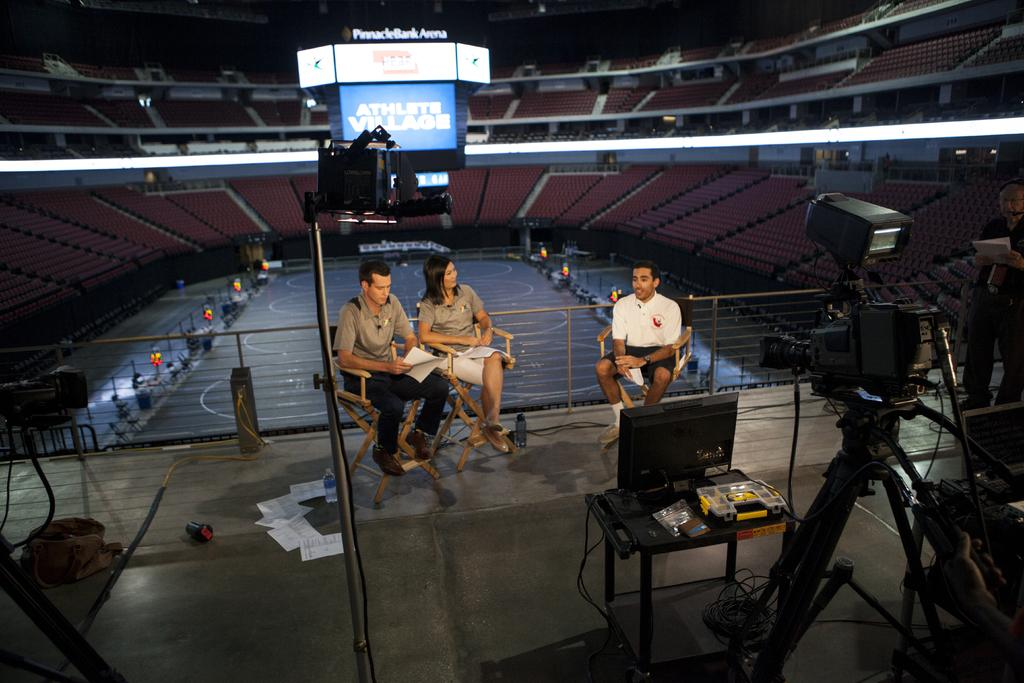How many people are sitting in the image? There are three persons sitting on chairs in the image. What can be seen on the right side of the image? There is a camera on the right side of the image. Are there any additional seats visible in the image? Yes, there are seats visible in the background of the image. What type of plate is being used for learning in the image? There is no plate or learning activity present in the image. 